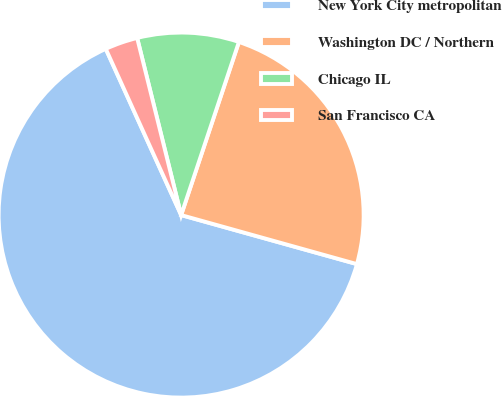Convert chart. <chart><loc_0><loc_0><loc_500><loc_500><pie_chart><fcel>New York City metropolitan<fcel>Washington DC / Northern<fcel>Chicago IL<fcel>San Francisco CA<nl><fcel>63.89%<fcel>24.2%<fcel>9.0%<fcel>2.9%<nl></chart> 